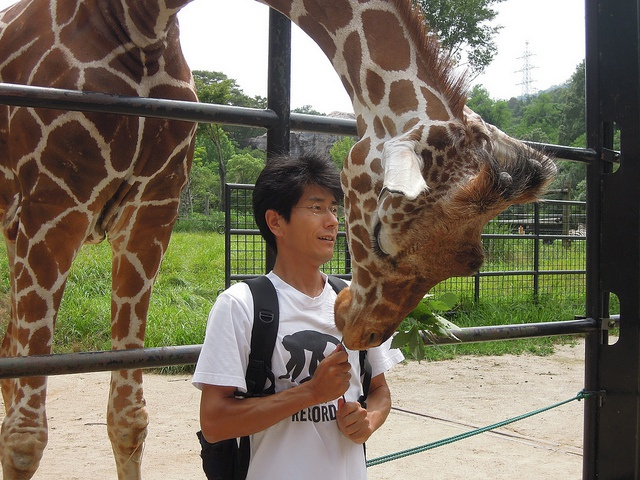Describe the objects in this image and their specific colors. I can see giraffe in white, maroon, black, and gray tones, people in white, black, darkgray, lightgray, and brown tones, and backpack in white, black, gray, darkgray, and lightgray tones in this image. 